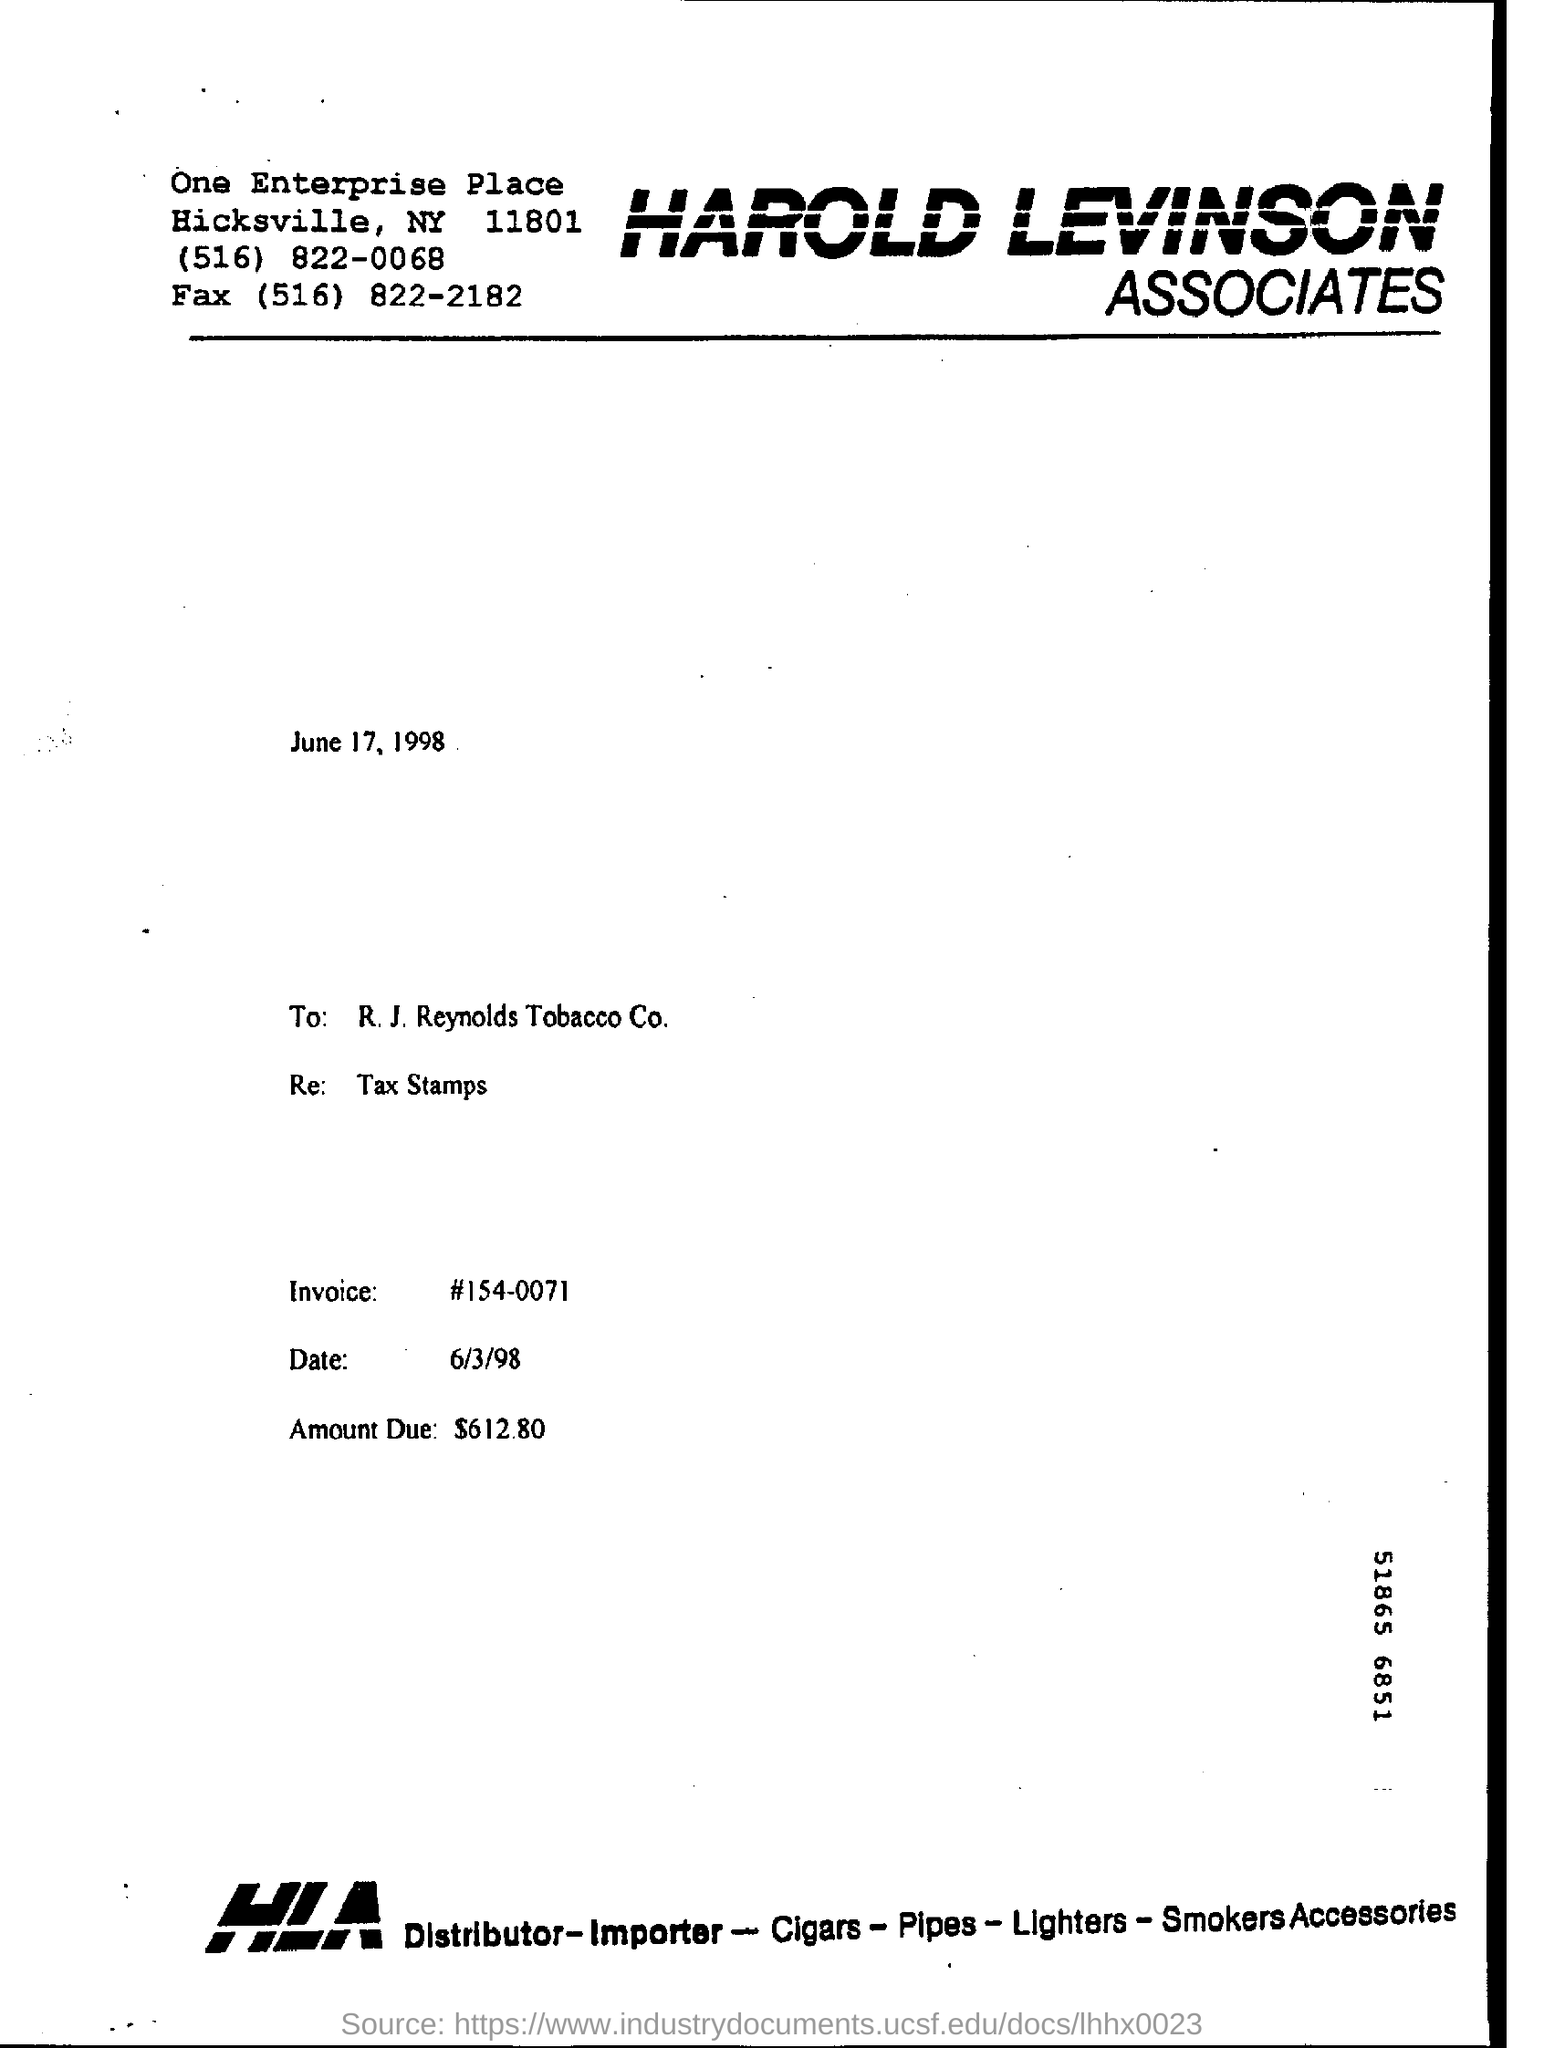Mention a couple of crucial points in this snapshot. The due amount is $612.80. The invoice number is 154-0071. 